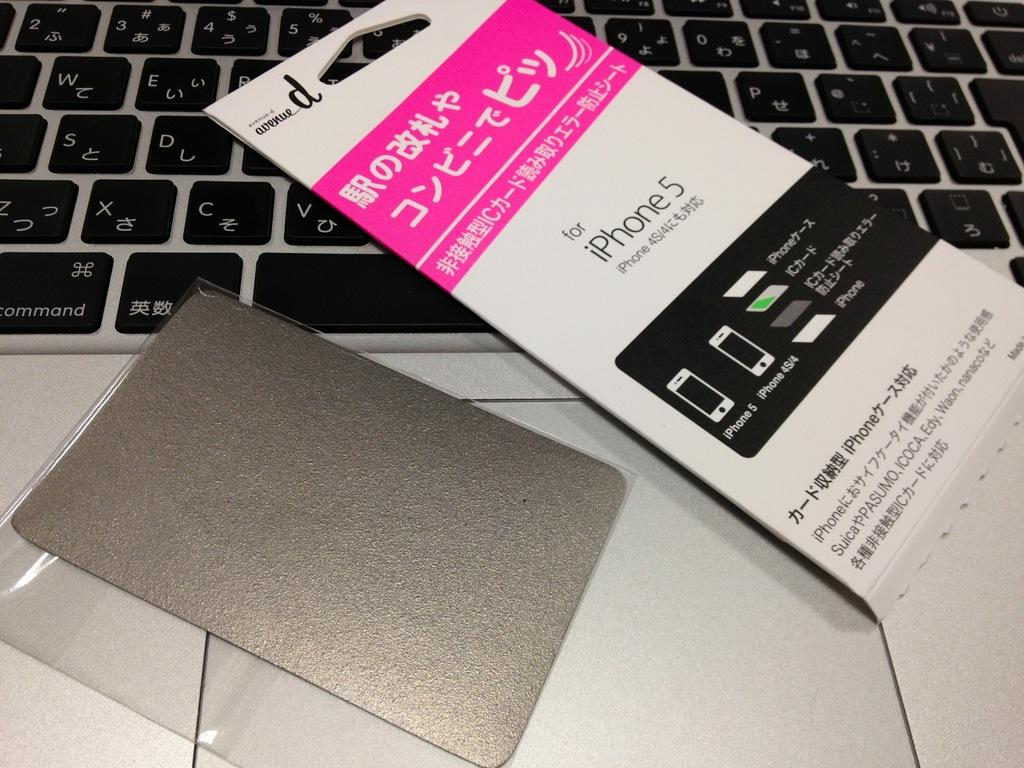<image>
Summarize the visual content of the image. a iPhone 5 packaging label on a keyboard 